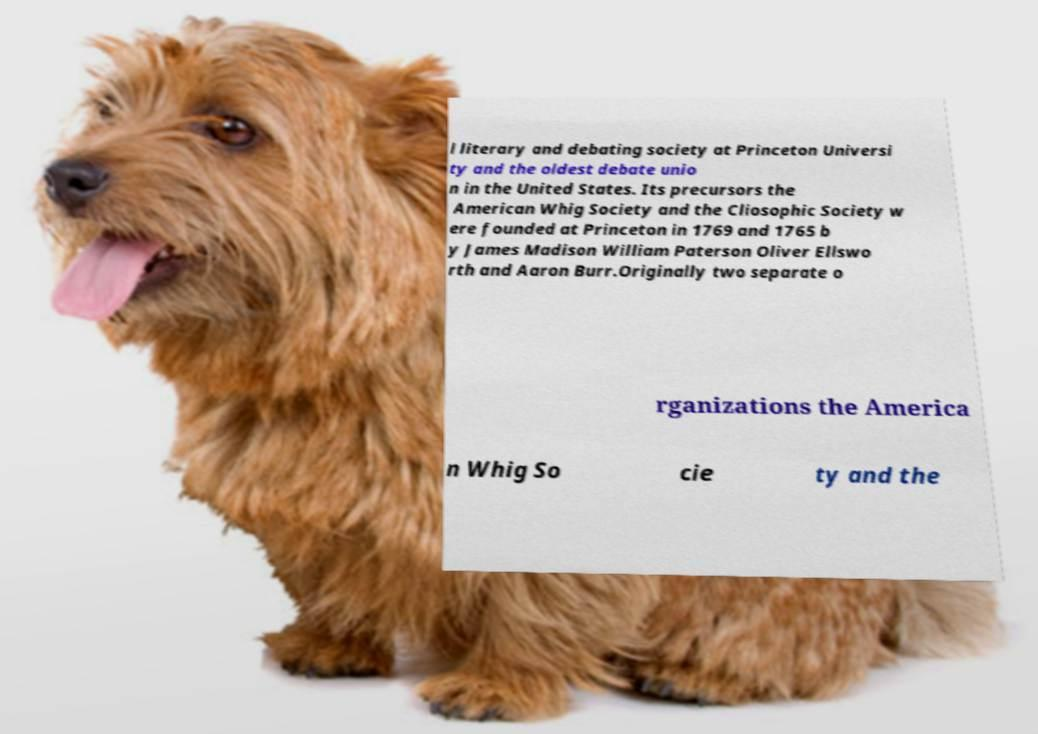Can you accurately transcribe the text from the provided image for me? l literary and debating society at Princeton Universi ty and the oldest debate unio n in the United States. Its precursors the American Whig Society and the Cliosophic Society w ere founded at Princeton in 1769 and 1765 b y James Madison William Paterson Oliver Ellswo rth and Aaron Burr.Originally two separate o rganizations the America n Whig So cie ty and the 